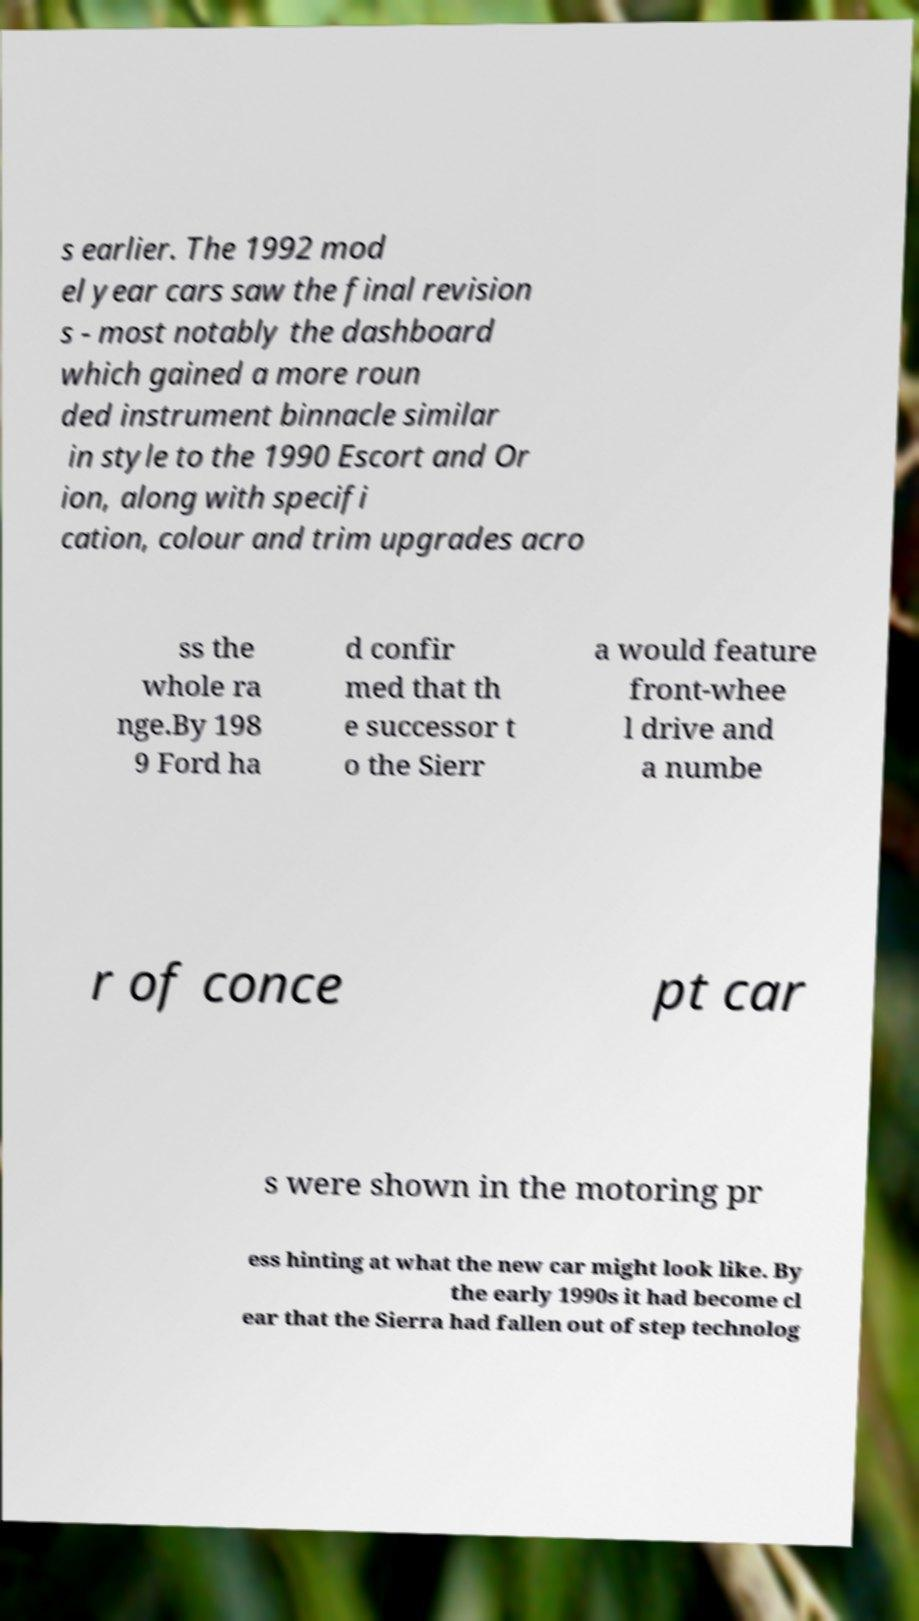I need the written content from this picture converted into text. Can you do that? s earlier. The 1992 mod el year cars saw the final revision s - most notably the dashboard which gained a more roun ded instrument binnacle similar in style to the 1990 Escort and Or ion, along with specifi cation, colour and trim upgrades acro ss the whole ra nge.By 198 9 Ford ha d confir med that th e successor t o the Sierr a would feature front-whee l drive and a numbe r of conce pt car s were shown in the motoring pr ess hinting at what the new car might look like. By the early 1990s it had become cl ear that the Sierra had fallen out of step technolog 